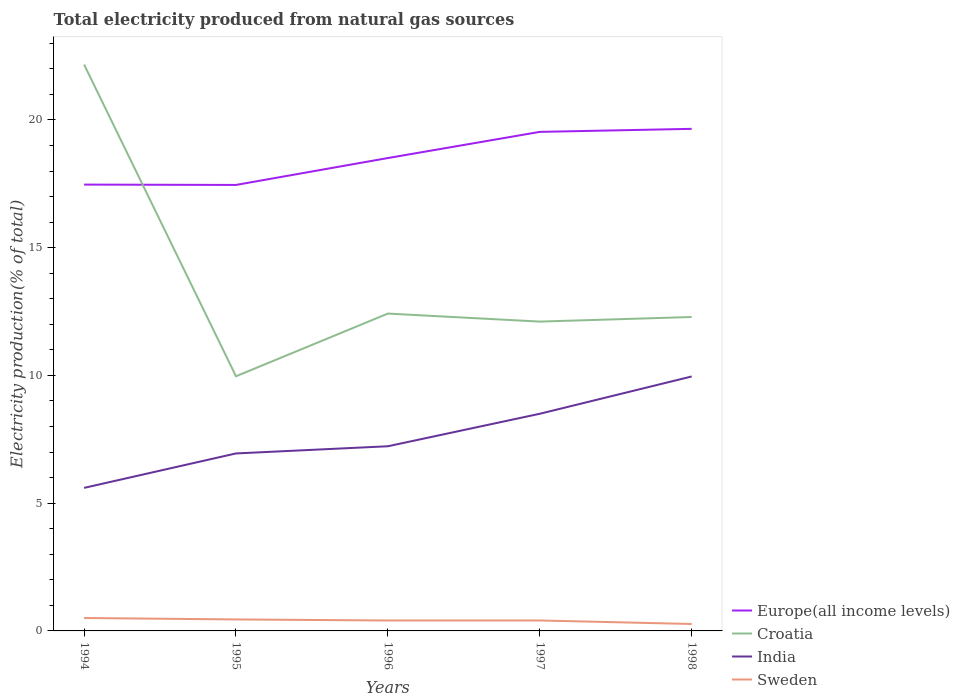Is the number of lines equal to the number of legend labels?
Make the answer very short. Yes. Across all years, what is the maximum total electricity produced in Europe(all income levels)?
Your response must be concise. 17.46. What is the total total electricity produced in Europe(all income levels) in the graph?
Keep it short and to the point. -1.04. What is the difference between the highest and the second highest total electricity produced in Europe(all income levels)?
Provide a succinct answer. 2.2. What is the difference between the highest and the lowest total electricity produced in Sweden?
Provide a short and direct response. 2. Is the total electricity produced in Europe(all income levels) strictly greater than the total electricity produced in Croatia over the years?
Your answer should be compact. No. How many lines are there?
Offer a very short reply. 4. Does the graph contain grids?
Give a very brief answer. No. How are the legend labels stacked?
Keep it short and to the point. Vertical. What is the title of the graph?
Your answer should be very brief. Total electricity produced from natural gas sources. What is the label or title of the Y-axis?
Your response must be concise. Electricity production(% of total). What is the Electricity production(% of total) in Europe(all income levels) in 1994?
Ensure brevity in your answer.  17.47. What is the Electricity production(% of total) in Croatia in 1994?
Offer a very short reply. 22.17. What is the Electricity production(% of total) in India in 1994?
Offer a terse response. 5.6. What is the Electricity production(% of total) of Sweden in 1994?
Make the answer very short. 0.51. What is the Electricity production(% of total) in Europe(all income levels) in 1995?
Provide a short and direct response. 17.46. What is the Electricity production(% of total) in Croatia in 1995?
Give a very brief answer. 9.97. What is the Electricity production(% of total) of India in 1995?
Give a very brief answer. 6.95. What is the Electricity production(% of total) in Sweden in 1995?
Give a very brief answer. 0.45. What is the Electricity production(% of total) in Europe(all income levels) in 1996?
Make the answer very short. 18.51. What is the Electricity production(% of total) of Croatia in 1996?
Offer a terse response. 12.42. What is the Electricity production(% of total) of India in 1996?
Your response must be concise. 7.23. What is the Electricity production(% of total) of Sweden in 1996?
Ensure brevity in your answer.  0.41. What is the Electricity production(% of total) of Europe(all income levels) in 1997?
Your answer should be compact. 19.53. What is the Electricity production(% of total) of Croatia in 1997?
Provide a succinct answer. 12.11. What is the Electricity production(% of total) of India in 1997?
Keep it short and to the point. 8.5. What is the Electricity production(% of total) in Sweden in 1997?
Provide a short and direct response. 0.41. What is the Electricity production(% of total) in Europe(all income levels) in 1998?
Ensure brevity in your answer.  19.65. What is the Electricity production(% of total) in Croatia in 1998?
Provide a short and direct response. 12.29. What is the Electricity production(% of total) of India in 1998?
Provide a succinct answer. 9.96. What is the Electricity production(% of total) of Sweden in 1998?
Make the answer very short. 0.27. Across all years, what is the maximum Electricity production(% of total) of Europe(all income levels)?
Give a very brief answer. 19.65. Across all years, what is the maximum Electricity production(% of total) in Croatia?
Provide a short and direct response. 22.17. Across all years, what is the maximum Electricity production(% of total) of India?
Ensure brevity in your answer.  9.96. Across all years, what is the maximum Electricity production(% of total) of Sweden?
Provide a short and direct response. 0.51. Across all years, what is the minimum Electricity production(% of total) of Europe(all income levels)?
Give a very brief answer. 17.46. Across all years, what is the minimum Electricity production(% of total) of Croatia?
Make the answer very short. 9.97. Across all years, what is the minimum Electricity production(% of total) in India?
Your answer should be compact. 5.6. Across all years, what is the minimum Electricity production(% of total) in Sweden?
Provide a short and direct response. 0.27. What is the total Electricity production(% of total) in Europe(all income levels) in the graph?
Offer a very short reply. 92.63. What is the total Electricity production(% of total) in Croatia in the graph?
Keep it short and to the point. 68.96. What is the total Electricity production(% of total) in India in the graph?
Make the answer very short. 38.24. What is the total Electricity production(% of total) of Sweden in the graph?
Offer a terse response. 2.04. What is the difference between the Electricity production(% of total) of Europe(all income levels) in 1994 and that in 1995?
Provide a succinct answer. 0.01. What is the difference between the Electricity production(% of total) in Croatia in 1994 and that in 1995?
Your answer should be compact. 12.2. What is the difference between the Electricity production(% of total) of India in 1994 and that in 1995?
Ensure brevity in your answer.  -1.35. What is the difference between the Electricity production(% of total) in Sweden in 1994 and that in 1995?
Your answer should be compact. 0.06. What is the difference between the Electricity production(% of total) of Europe(all income levels) in 1994 and that in 1996?
Your response must be concise. -1.04. What is the difference between the Electricity production(% of total) of Croatia in 1994 and that in 1996?
Your answer should be very brief. 9.75. What is the difference between the Electricity production(% of total) in India in 1994 and that in 1996?
Give a very brief answer. -1.63. What is the difference between the Electricity production(% of total) of Sweden in 1994 and that in 1996?
Make the answer very short. 0.1. What is the difference between the Electricity production(% of total) of Europe(all income levels) in 1994 and that in 1997?
Give a very brief answer. -2.06. What is the difference between the Electricity production(% of total) in Croatia in 1994 and that in 1997?
Offer a very short reply. 10.06. What is the difference between the Electricity production(% of total) in India in 1994 and that in 1997?
Your answer should be very brief. -2.9. What is the difference between the Electricity production(% of total) in Sweden in 1994 and that in 1997?
Give a very brief answer. 0.1. What is the difference between the Electricity production(% of total) of Europe(all income levels) in 1994 and that in 1998?
Your response must be concise. -2.18. What is the difference between the Electricity production(% of total) in Croatia in 1994 and that in 1998?
Keep it short and to the point. 9.88. What is the difference between the Electricity production(% of total) in India in 1994 and that in 1998?
Offer a terse response. -4.36. What is the difference between the Electricity production(% of total) in Sweden in 1994 and that in 1998?
Keep it short and to the point. 0.23. What is the difference between the Electricity production(% of total) in Europe(all income levels) in 1995 and that in 1996?
Ensure brevity in your answer.  -1.05. What is the difference between the Electricity production(% of total) in Croatia in 1995 and that in 1996?
Keep it short and to the point. -2.45. What is the difference between the Electricity production(% of total) of India in 1995 and that in 1996?
Provide a succinct answer. -0.28. What is the difference between the Electricity production(% of total) in Sweden in 1995 and that in 1996?
Ensure brevity in your answer.  0.04. What is the difference between the Electricity production(% of total) of Europe(all income levels) in 1995 and that in 1997?
Ensure brevity in your answer.  -2.08. What is the difference between the Electricity production(% of total) in Croatia in 1995 and that in 1997?
Provide a short and direct response. -2.14. What is the difference between the Electricity production(% of total) of India in 1995 and that in 1997?
Offer a terse response. -1.55. What is the difference between the Electricity production(% of total) of Sweden in 1995 and that in 1997?
Provide a short and direct response. 0.04. What is the difference between the Electricity production(% of total) of Europe(all income levels) in 1995 and that in 1998?
Keep it short and to the point. -2.2. What is the difference between the Electricity production(% of total) of Croatia in 1995 and that in 1998?
Your answer should be very brief. -2.32. What is the difference between the Electricity production(% of total) in India in 1995 and that in 1998?
Keep it short and to the point. -3.01. What is the difference between the Electricity production(% of total) in Sweden in 1995 and that in 1998?
Offer a terse response. 0.18. What is the difference between the Electricity production(% of total) in Europe(all income levels) in 1996 and that in 1997?
Provide a short and direct response. -1.02. What is the difference between the Electricity production(% of total) of Croatia in 1996 and that in 1997?
Give a very brief answer. 0.31. What is the difference between the Electricity production(% of total) of India in 1996 and that in 1997?
Give a very brief answer. -1.27. What is the difference between the Electricity production(% of total) in Sweden in 1996 and that in 1997?
Offer a terse response. -0. What is the difference between the Electricity production(% of total) of Europe(all income levels) in 1996 and that in 1998?
Keep it short and to the point. -1.14. What is the difference between the Electricity production(% of total) in Croatia in 1996 and that in 1998?
Your response must be concise. 0.13. What is the difference between the Electricity production(% of total) of India in 1996 and that in 1998?
Your response must be concise. -2.73. What is the difference between the Electricity production(% of total) in Sweden in 1996 and that in 1998?
Offer a terse response. 0.14. What is the difference between the Electricity production(% of total) of Europe(all income levels) in 1997 and that in 1998?
Make the answer very short. -0.12. What is the difference between the Electricity production(% of total) of Croatia in 1997 and that in 1998?
Your answer should be very brief. -0.18. What is the difference between the Electricity production(% of total) in India in 1997 and that in 1998?
Make the answer very short. -1.46. What is the difference between the Electricity production(% of total) of Sweden in 1997 and that in 1998?
Make the answer very short. 0.14. What is the difference between the Electricity production(% of total) in Europe(all income levels) in 1994 and the Electricity production(% of total) in Croatia in 1995?
Give a very brief answer. 7.5. What is the difference between the Electricity production(% of total) of Europe(all income levels) in 1994 and the Electricity production(% of total) of India in 1995?
Make the answer very short. 10.52. What is the difference between the Electricity production(% of total) of Europe(all income levels) in 1994 and the Electricity production(% of total) of Sweden in 1995?
Offer a terse response. 17.02. What is the difference between the Electricity production(% of total) in Croatia in 1994 and the Electricity production(% of total) in India in 1995?
Your answer should be compact. 15.22. What is the difference between the Electricity production(% of total) of Croatia in 1994 and the Electricity production(% of total) of Sweden in 1995?
Your response must be concise. 21.72. What is the difference between the Electricity production(% of total) in India in 1994 and the Electricity production(% of total) in Sweden in 1995?
Offer a very short reply. 5.15. What is the difference between the Electricity production(% of total) of Europe(all income levels) in 1994 and the Electricity production(% of total) of Croatia in 1996?
Offer a very short reply. 5.05. What is the difference between the Electricity production(% of total) in Europe(all income levels) in 1994 and the Electricity production(% of total) in India in 1996?
Make the answer very short. 10.24. What is the difference between the Electricity production(% of total) of Europe(all income levels) in 1994 and the Electricity production(% of total) of Sweden in 1996?
Your answer should be very brief. 17.06. What is the difference between the Electricity production(% of total) in Croatia in 1994 and the Electricity production(% of total) in India in 1996?
Offer a very short reply. 14.94. What is the difference between the Electricity production(% of total) in Croatia in 1994 and the Electricity production(% of total) in Sweden in 1996?
Your answer should be compact. 21.76. What is the difference between the Electricity production(% of total) of India in 1994 and the Electricity production(% of total) of Sweden in 1996?
Ensure brevity in your answer.  5.19. What is the difference between the Electricity production(% of total) in Europe(all income levels) in 1994 and the Electricity production(% of total) in Croatia in 1997?
Your answer should be very brief. 5.36. What is the difference between the Electricity production(% of total) in Europe(all income levels) in 1994 and the Electricity production(% of total) in India in 1997?
Provide a short and direct response. 8.97. What is the difference between the Electricity production(% of total) of Europe(all income levels) in 1994 and the Electricity production(% of total) of Sweden in 1997?
Give a very brief answer. 17.06. What is the difference between the Electricity production(% of total) in Croatia in 1994 and the Electricity production(% of total) in India in 1997?
Your response must be concise. 13.67. What is the difference between the Electricity production(% of total) of Croatia in 1994 and the Electricity production(% of total) of Sweden in 1997?
Your response must be concise. 21.76. What is the difference between the Electricity production(% of total) of India in 1994 and the Electricity production(% of total) of Sweden in 1997?
Provide a short and direct response. 5.19. What is the difference between the Electricity production(% of total) in Europe(all income levels) in 1994 and the Electricity production(% of total) in Croatia in 1998?
Your response must be concise. 5.18. What is the difference between the Electricity production(% of total) in Europe(all income levels) in 1994 and the Electricity production(% of total) in India in 1998?
Provide a short and direct response. 7.51. What is the difference between the Electricity production(% of total) in Europe(all income levels) in 1994 and the Electricity production(% of total) in Sweden in 1998?
Your answer should be very brief. 17.2. What is the difference between the Electricity production(% of total) in Croatia in 1994 and the Electricity production(% of total) in India in 1998?
Ensure brevity in your answer.  12.21. What is the difference between the Electricity production(% of total) of Croatia in 1994 and the Electricity production(% of total) of Sweden in 1998?
Ensure brevity in your answer.  21.9. What is the difference between the Electricity production(% of total) in India in 1994 and the Electricity production(% of total) in Sweden in 1998?
Provide a short and direct response. 5.33. What is the difference between the Electricity production(% of total) of Europe(all income levels) in 1995 and the Electricity production(% of total) of Croatia in 1996?
Provide a succinct answer. 5.04. What is the difference between the Electricity production(% of total) in Europe(all income levels) in 1995 and the Electricity production(% of total) in India in 1996?
Give a very brief answer. 10.23. What is the difference between the Electricity production(% of total) of Europe(all income levels) in 1995 and the Electricity production(% of total) of Sweden in 1996?
Offer a very short reply. 17.05. What is the difference between the Electricity production(% of total) of Croatia in 1995 and the Electricity production(% of total) of India in 1996?
Provide a succinct answer. 2.74. What is the difference between the Electricity production(% of total) in Croatia in 1995 and the Electricity production(% of total) in Sweden in 1996?
Give a very brief answer. 9.56. What is the difference between the Electricity production(% of total) of India in 1995 and the Electricity production(% of total) of Sweden in 1996?
Your answer should be very brief. 6.54. What is the difference between the Electricity production(% of total) of Europe(all income levels) in 1995 and the Electricity production(% of total) of Croatia in 1997?
Your answer should be compact. 5.35. What is the difference between the Electricity production(% of total) of Europe(all income levels) in 1995 and the Electricity production(% of total) of India in 1997?
Offer a very short reply. 8.96. What is the difference between the Electricity production(% of total) in Europe(all income levels) in 1995 and the Electricity production(% of total) in Sweden in 1997?
Provide a short and direct response. 17.05. What is the difference between the Electricity production(% of total) in Croatia in 1995 and the Electricity production(% of total) in India in 1997?
Provide a succinct answer. 1.47. What is the difference between the Electricity production(% of total) in Croatia in 1995 and the Electricity production(% of total) in Sweden in 1997?
Your answer should be very brief. 9.56. What is the difference between the Electricity production(% of total) in India in 1995 and the Electricity production(% of total) in Sweden in 1997?
Offer a terse response. 6.54. What is the difference between the Electricity production(% of total) in Europe(all income levels) in 1995 and the Electricity production(% of total) in Croatia in 1998?
Keep it short and to the point. 5.17. What is the difference between the Electricity production(% of total) in Europe(all income levels) in 1995 and the Electricity production(% of total) in India in 1998?
Make the answer very short. 7.5. What is the difference between the Electricity production(% of total) of Europe(all income levels) in 1995 and the Electricity production(% of total) of Sweden in 1998?
Keep it short and to the point. 17.19. What is the difference between the Electricity production(% of total) of Croatia in 1995 and the Electricity production(% of total) of India in 1998?
Keep it short and to the point. 0.01. What is the difference between the Electricity production(% of total) in Croatia in 1995 and the Electricity production(% of total) in Sweden in 1998?
Offer a terse response. 9.7. What is the difference between the Electricity production(% of total) in India in 1995 and the Electricity production(% of total) in Sweden in 1998?
Provide a succinct answer. 6.68. What is the difference between the Electricity production(% of total) in Europe(all income levels) in 1996 and the Electricity production(% of total) in Croatia in 1997?
Keep it short and to the point. 6.4. What is the difference between the Electricity production(% of total) in Europe(all income levels) in 1996 and the Electricity production(% of total) in India in 1997?
Your answer should be very brief. 10.01. What is the difference between the Electricity production(% of total) in Europe(all income levels) in 1996 and the Electricity production(% of total) in Sweden in 1997?
Make the answer very short. 18.1. What is the difference between the Electricity production(% of total) of Croatia in 1996 and the Electricity production(% of total) of India in 1997?
Your answer should be very brief. 3.92. What is the difference between the Electricity production(% of total) of Croatia in 1996 and the Electricity production(% of total) of Sweden in 1997?
Your answer should be compact. 12.01. What is the difference between the Electricity production(% of total) in India in 1996 and the Electricity production(% of total) in Sweden in 1997?
Your answer should be compact. 6.82. What is the difference between the Electricity production(% of total) in Europe(all income levels) in 1996 and the Electricity production(% of total) in Croatia in 1998?
Your answer should be compact. 6.22. What is the difference between the Electricity production(% of total) of Europe(all income levels) in 1996 and the Electricity production(% of total) of India in 1998?
Keep it short and to the point. 8.55. What is the difference between the Electricity production(% of total) of Europe(all income levels) in 1996 and the Electricity production(% of total) of Sweden in 1998?
Ensure brevity in your answer.  18.24. What is the difference between the Electricity production(% of total) of Croatia in 1996 and the Electricity production(% of total) of India in 1998?
Make the answer very short. 2.46. What is the difference between the Electricity production(% of total) in Croatia in 1996 and the Electricity production(% of total) in Sweden in 1998?
Offer a terse response. 12.15. What is the difference between the Electricity production(% of total) in India in 1996 and the Electricity production(% of total) in Sweden in 1998?
Offer a very short reply. 6.96. What is the difference between the Electricity production(% of total) of Europe(all income levels) in 1997 and the Electricity production(% of total) of Croatia in 1998?
Your answer should be very brief. 7.25. What is the difference between the Electricity production(% of total) of Europe(all income levels) in 1997 and the Electricity production(% of total) of India in 1998?
Your answer should be compact. 9.57. What is the difference between the Electricity production(% of total) in Europe(all income levels) in 1997 and the Electricity production(% of total) in Sweden in 1998?
Provide a short and direct response. 19.26. What is the difference between the Electricity production(% of total) of Croatia in 1997 and the Electricity production(% of total) of India in 1998?
Your answer should be very brief. 2.15. What is the difference between the Electricity production(% of total) in Croatia in 1997 and the Electricity production(% of total) in Sweden in 1998?
Your answer should be compact. 11.84. What is the difference between the Electricity production(% of total) in India in 1997 and the Electricity production(% of total) in Sweden in 1998?
Your answer should be very brief. 8.23. What is the average Electricity production(% of total) in Europe(all income levels) per year?
Your answer should be very brief. 18.53. What is the average Electricity production(% of total) in Croatia per year?
Ensure brevity in your answer.  13.79. What is the average Electricity production(% of total) of India per year?
Your response must be concise. 7.65. What is the average Electricity production(% of total) in Sweden per year?
Ensure brevity in your answer.  0.41. In the year 1994, what is the difference between the Electricity production(% of total) of Europe(all income levels) and Electricity production(% of total) of Croatia?
Keep it short and to the point. -4.7. In the year 1994, what is the difference between the Electricity production(% of total) of Europe(all income levels) and Electricity production(% of total) of India?
Your answer should be compact. 11.87. In the year 1994, what is the difference between the Electricity production(% of total) of Europe(all income levels) and Electricity production(% of total) of Sweden?
Your response must be concise. 16.96. In the year 1994, what is the difference between the Electricity production(% of total) of Croatia and Electricity production(% of total) of India?
Offer a very short reply. 16.57. In the year 1994, what is the difference between the Electricity production(% of total) in Croatia and Electricity production(% of total) in Sweden?
Your answer should be compact. 21.66. In the year 1994, what is the difference between the Electricity production(% of total) in India and Electricity production(% of total) in Sweden?
Your response must be concise. 5.09. In the year 1995, what is the difference between the Electricity production(% of total) of Europe(all income levels) and Electricity production(% of total) of Croatia?
Ensure brevity in your answer.  7.49. In the year 1995, what is the difference between the Electricity production(% of total) in Europe(all income levels) and Electricity production(% of total) in India?
Give a very brief answer. 10.51. In the year 1995, what is the difference between the Electricity production(% of total) in Europe(all income levels) and Electricity production(% of total) in Sweden?
Offer a terse response. 17.01. In the year 1995, what is the difference between the Electricity production(% of total) in Croatia and Electricity production(% of total) in India?
Give a very brief answer. 3.02. In the year 1995, what is the difference between the Electricity production(% of total) in Croatia and Electricity production(% of total) in Sweden?
Ensure brevity in your answer.  9.52. In the year 1995, what is the difference between the Electricity production(% of total) in India and Electricity production(% of total) in Sweden?
Offer a terse response. 6.5. In the year 1996, what is the difference between the Electricity production(% of total) in Europe(all income levels) and Electricity production(% of total) in Croatia?
Offer a very short reply. 6.09. In the year 1996, what is the difference between the Electricity production(% of total) in Europe(all income levels) and Electricity production(% of total) in India?
Your answer should be compact. 11.28. In the year 1996, what is the difference between the Electricity production(% of total) of Europe(all income levels) and Electricity production(% of total) of Sweden?
Make the answer very short. 18.1. In the year 1996, what is the difference between the Electricity production(% of total) in Croatia and Electricity production(% of total) in India?
Provide a short and direct response. 5.19. In the year 1996, what is the difference between the Electricity production(% of total) of Croatia and Electricity production(% of total) of Sweden?
Ensure brevity in your answer.  12.01. In the year 1996, what is the difference between the Electricity production(% of total) of India and Electricity production(% of total) of Sweden?
Your answer should be very brief. 6.82. In the year 1997, what is the difference between the Electricity production(% of total) of Europe(all income levels) and Electricity production(% of total) of Croatia?
Provide a succinct answer. 7.43. In the year 1997, what is the difference between the Electricity production(% of total) in Europe(all income levels) and Electricity production(% of total) in India?
Your answer should be compact. 11.03. In the year 1997, what is the difference between the Electricity production(% of total) of Europe(all income levels) and Electricity production(% of total) of Sweden?
Give a very brief answer. 19.13. In the year 1997, what is the difference between the Electricity production(% of total) of Croatia and Electricity production(% of total) of India?
Ensure brevity in your answer.  3.61. In the year 1997, what is the difference between the Electricity production(% of total) of Croatia and Electricity production(% of total) of Sweden?
Your answer should be compact. 11.7. In the year 1997, what is the difference between the Electricity production(% of total) of India and Electricity production(% of total) of Sweden?
Ensure brevity in your answer.  8.09. In the year 1998, what is the difference between the Electricity production(% of total) of Europe(all income levels) and Electricity production(% of total) of Croatia?
Give a very brief answer. 7.37. In the year 1998, what is the difference between the Electricity production(% of total) in Europe(all income levels) and Electricity production(% of total) in India?
Your answer should be very brief. 9.69. In the year 1998, what is the difference between the Electricity production(% of total) in Europe(all income levels) and Electricity production(% of total) in Sweden?
Your answer should be compact. 19.38. In the year 1998, what is the difference between the Electricity production(% of total) of Croatia and Electricity production(% of total) of India?
Offer a terse response. 2.33. In the year 1998, what is the difference between the Electricity production(% of total) in Croatia and Electricity production(% of total) in Sweden?
Provide a succinct answer. 12.02. In the year 1998, what is the difference between the Electricity production(% of total) in India and Electricity production(% of total) in Sweden?
Make the answer very short. 9.69. What is the ratio of the Electricity production(% of total) of Croatia in 1994 to that in 1995?
Offer a very short reply. 2.22. What is the ratio of the Electricity production(% of total) in India in 1994 to that in 1995?
Provide a short and direct response. 0.81. What is the ratio of the Electricity production(% of total) in Sweden in 1994 to that in 1995?
Keep it short and to the point. 1.12. What is the ratio of the Electricity production(% of total) in Europe(all income levels) in 1994 to that in 1996?
Your answer should be compact. 0.94. What is the ratio of the Electricity production(% of total) in Croatia in 1994 to that in 1996?
Keep it short and to the point. 1.78. What is the ratio of the Electricity production(% of total) in India in 1994 to that in 1996?
Give a very brief answer. 0.77. What is the ratio of the Electricity production(% of total) in Sweden in 1994 to that in 1996?
Your answer should be compact. 1.24. What is the ratio of the Electricity production(% of total) in Europe(all income levels) in 1994 to that in 1997?
Provide a succinct answer. 0.89. What is the ratio of the Electricity production(% of total) in Croatia in 1994 to that in 1997?
Your answer should be compact. 1.83. What is the ratio of the Electricity production(% of total) of India in 1994 to that in 1997?
Provide a succinct answer. 0.66. What is the ratio of the Electricity production(% of total) in Sweden in 1994 to that in 1997?
Your response must be concise. 1.24. What is the ratio of the Electricity production(% of total) in Europe(all income levels) in 1994 to that in 1998?
Keep it short and to the point. 0.89. What is the ratio of the Electricity production(% of total) in Croatia in 1994 to that in 1998?
Offer a very short reply. 1.8. What is the ratio of the Electricity production(% of total) in India in 1994 to that in 1998?
Provide a short and direct response. 0.56. What is the ratio of the Electricity production(% of total) of Sweden in 1994 to that in 1998?
Make the answer very short. 1.86. What is the ratio of the Electricity production(% of total) of Europe(all income levels) in 1995 to that in 1996?
Offer a terse response. 0.94. What is the ratio of the Electricity production(% of total) in Croatia in 1995 to that in 1996?
Your answer should be very brief. 0.8. What is the ratio of the Electricity production(% of total) of India in 1995 to that in 1996?
Make the answer very short. 0.96. What is the ratio of the Electricity production(% of total) in Sweden in 1995 to that in 1996?
Give a very brief answer. 1.1. What is the ratio of the Electricity production(% of total) of Europe(all income levels) in 1995 to that in 1997?
Provide a short and direct response. 0.89. What is the ratio of the Electricity production(% of total) in Croatia in 1995 to that in 1997?
Provide a short and direct response. 0.82. What is the ratio of the Electricity production(% of total) in India in 1995 to that in 1997?
Offer a very short reply. 0.82. What is the ratio of the Electricity production(% of total) of Sweden in 1995 to that in 1997?
Your response must be concise. 1.1. What is the ratio of the Electricity production(% of total) of Europe(all income levels) in 1995 to that in 1998?
Give a very brief answer. 0.89. What is the ratio of the Electricity production(% of total) of Croatia in 1995 to that in 1998?
Provide a succinct answer. 0.81. What is the ratio of the Electricity production(% of total) in India in 1995 to that in 1998?
Provide a succinct answer. 0.7. What is the ratio of the Electricity production(% of total) in Sweden in 1995 to that in 1998?
Offer a terse response. 1.66. What is the ratio of the Electricity production(% of total) of Europe(all income levels) in 1996 to that in 1997?
Your answer should be compact. 0.95. What is the ratio of the Electricity production(% of total) of Croatia in 1996 to that in 1997?
Provide a short and direct response. 1.03. What is the ratio of the Electricity production(% of total) in India in 1996 to that in 1997?
Ensure brevity in your answer.  0.85. What is the ratio of the Electricity production(% of total) in Sweden in 1996 to that in 1997?
Keep it short and to the point. 1. What is the ratio of the Electricity production(% of total) of Europe(all income levels) in 1996 to that in 1998?
Ensure brevity in your answer.  0.94. What is the ratio of the Electricity production(% of total) in Croatia in 1996 to that in 1998?
Your answer should be very brief. 1.01. What is the ratio of the Electricity production(% of total) of India in 1996 to that in 1998?
Give a very brief answer. 0.73. What is the ratio of the Electricity production(% of total) of Sweden in 1996 to that in 1998?
Provide a short and direct response. 1.5. What is the ratio of the Electricity production(% of total) in Croatia in 1997 to that in 1998?
Provide a succinct answer. 0.99. What is the ratio of the Electricity production(% of total) in India in 1997 to that in 1998?
Make the answer very short. 0.85. What is the ratio of the Electricity production(% of total) of Sweden in 1997 to that in 1998?
Your response must be concise. 1.51. What is the difference between the highest and the second highest Electricity production(% of total) in Europe(all income levels)?
Keep it short and to the point. 0.12. What is the difference between the highest and the second highest Electricity production(% of total) of Croatia?
Offer a very short reply. 9.75. What is the difference between the highest and the second highest Electricity production(% of total) of India?
Your answer should be compact. 1.46. What is the difference between the highest and the second highest Electricity production(% of total) in Sweden?
Ensure brevity in your answer.  0.06. What is the difference between the highest and the lowest Electricity production(% of total) of Europe(all income levels)?
Give a very brief answer. 2.2. What is the difference between the highest and the lowest Electricity production(% of total) of Croatia?
Give a very brief answer. 12.2. What is the difference between the highest and the lowest Electricity production(% of total) of India?
Make the answer very short. 4.36. What is the difference between the highest and the lowest Electricity production(% of total) in Sweden?
Your response must be concise. 0.23. 